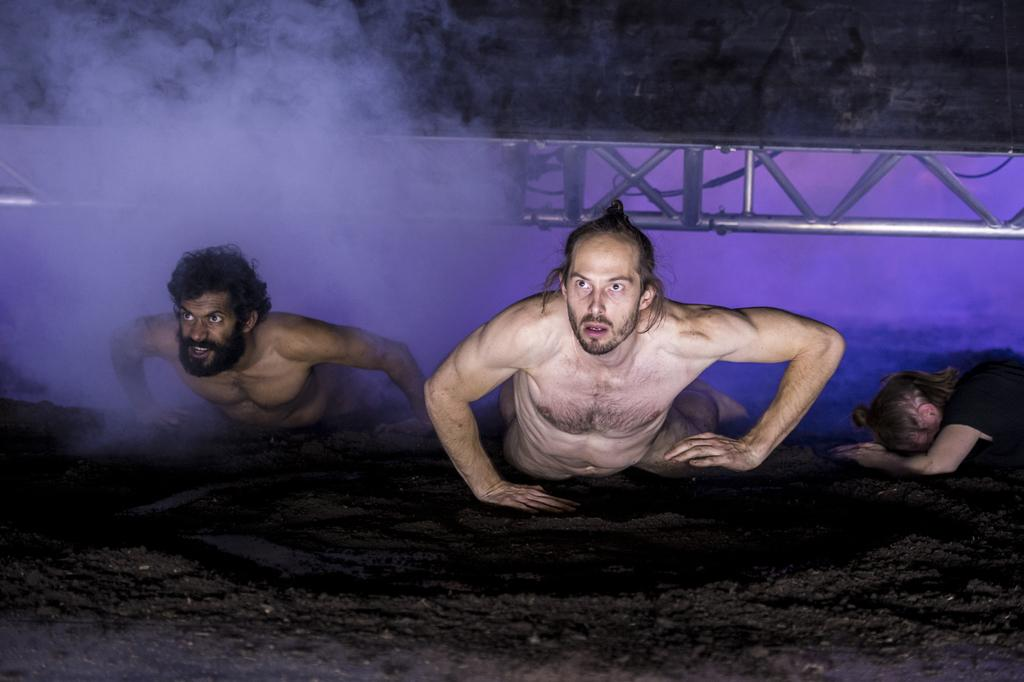How many people are present in the image? There are three people in the image. What is the surface that the people are on? The information provided does not specify the type of surface the people are on. What can be seen in the background of the image? There is smoke, rods, wires, and an unspecified object in the background of the image. Can you see a cemetery in the image? No, there is no cemetery present in the image. 